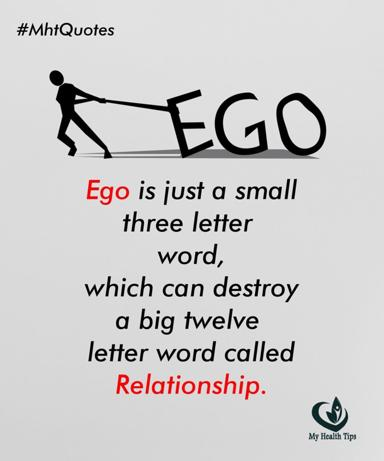How can ego affect relationships according to the quote? According to the quote in the image, ego, symbolized as a small yet powerful concept, has the ability to devastate relationships, which are significantly more complex and valuable. This portrayal emphasizes the destructive potential of letting personal pride or ego dominate one's actions and interactions, thereby threatening the stability and health of relationships. 